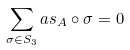Convert formula to latex. <formula><loc_0><loc_0><loc_500><loc_500>\sum _ { \sigma \in S _ { 3 } } a s _ { A } \circ \sigma = 0</formula> 